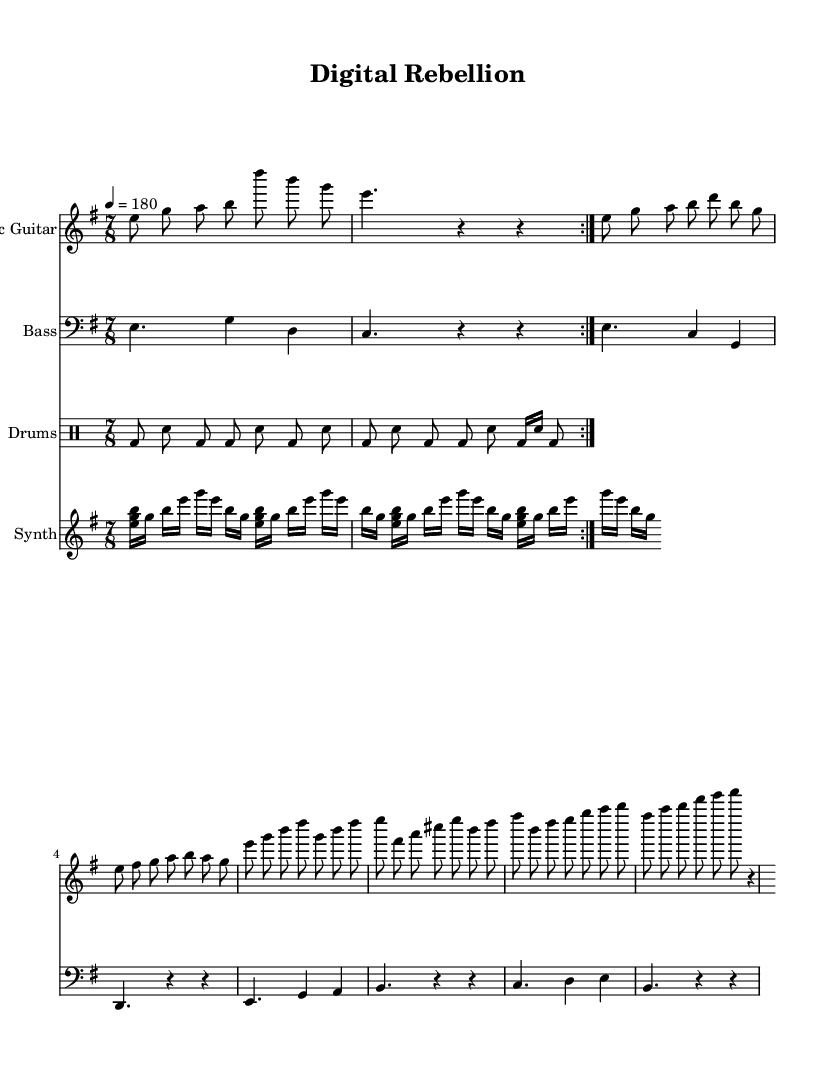What is the key signature of this music? The key signature is E minor, which has one sharp (F#). This can be identified by the key signature indicated at the beginning of the score.
Answer: E minor What is the time signature of this music? The time signature is 7/8, which is indicated after the key signature. This shows that there are seven beats per measure, and the eighth note gets the beat.
Answer: 7/8 What is the tempo marking of this music? The tempo marking is quarter note equals 180, which indicates how fast the piece should be played. This is specified at the beginning of the score next to the tempo indication.
Answer: 180 How many measures are in the verse section? The verse section consists of 6 measures. This can be calculated by counting the segments within the verse portion of the sheet music, marked accordingly.
Answer: 6 measures What instrument plays the arpeggiated pattern? The arpeggiated pattern is played by the synth. This is specified by the instrument name set at the beginning of the synth part in the score.
Answer: Synth What is the main rhythm pattern used in the drums? The main rhythm pattern is a basic punk rhythm, characterized by a bass drum and snare drum interplay. It can be recognized by the distinct patterns of bass and snare in the drum part.
Answer: Basic punk rhythm How many notes are in the chorus melody? The chorus melody contains 8 notes. This can be determined by counting the individual notes presented in the chorus section of the electric guitar part.
Answer: 8 notes 